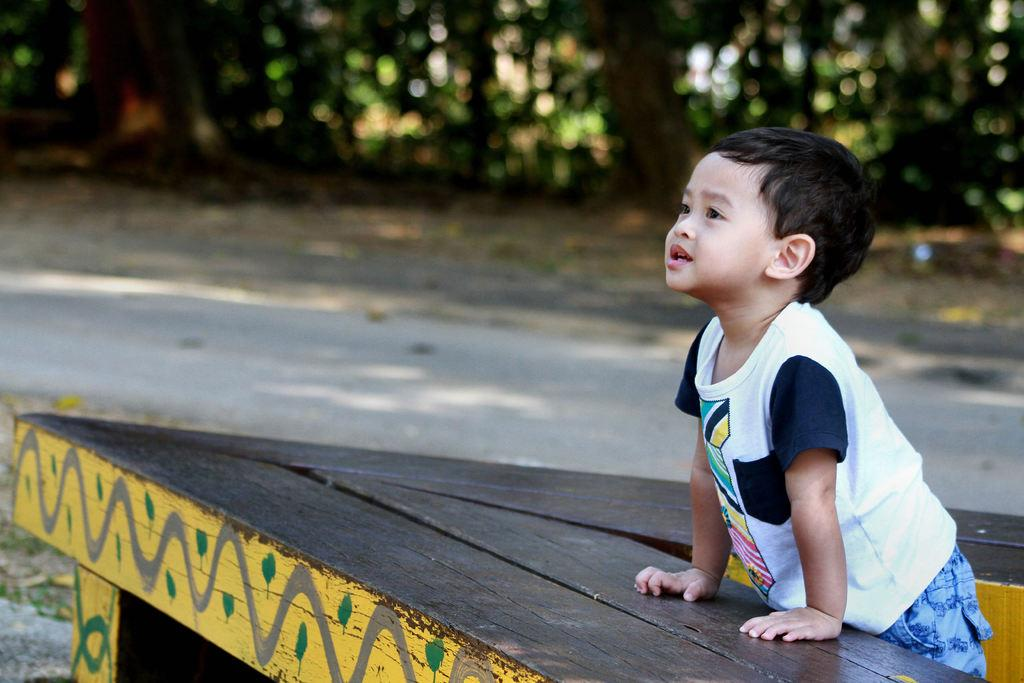Who is the main subject in the image? There is a boy in the image. What is the boy wearing? The boy is wearing a white t-shirt. What can be seen in the background of the image? There are trees in the background of the image. What type of instrument is the boy playing in the image? There is no instrument present in the image; the boy is not playing any instrument. 